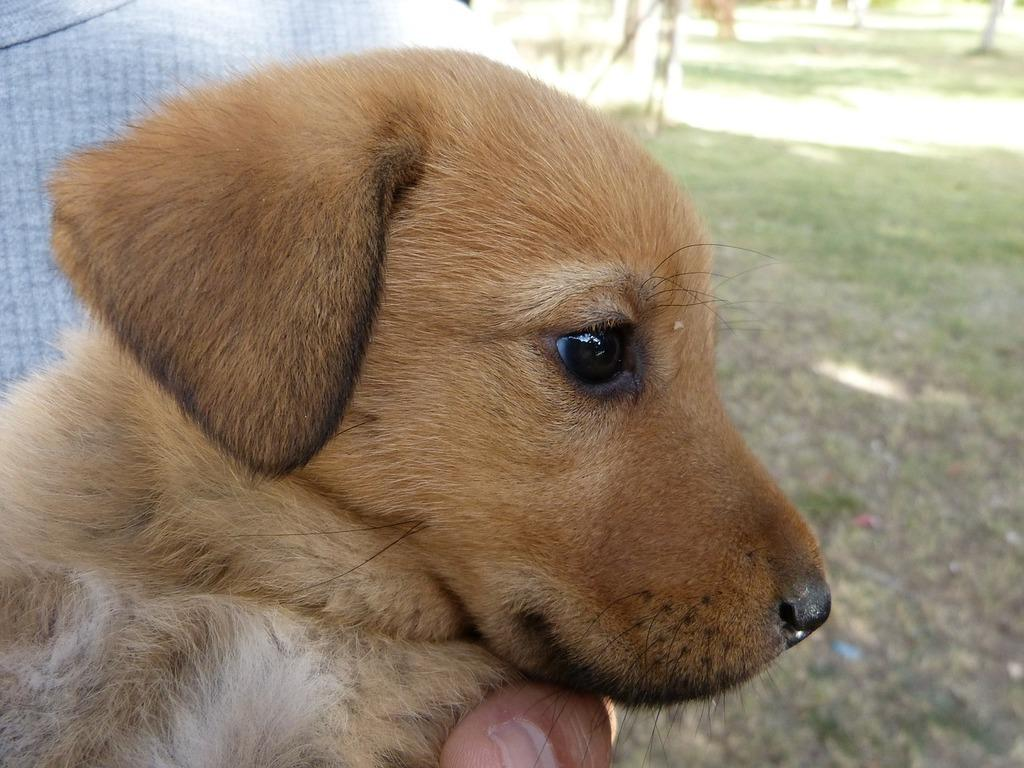What type of animal is in the image? There is a brown-colored puppy in the image. Can you describe the background of the image? There is grass on the right side of the image. What part of a human body is visible in the image? A human finger is visible at the bottom of the image. What type of volleyball is being played in the image? There is no volleyball present in the image. What is the puppy biting in the image? There is no indication in the image that the puppy is biting anything. 